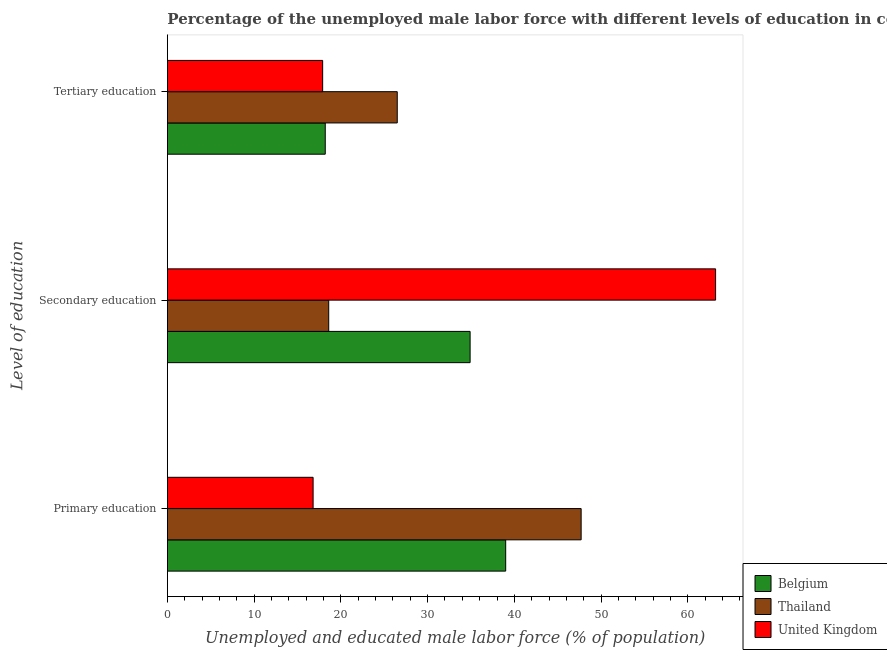Are the number of bars per tick equal to the number of legend labels?
Your response must be concise. Yes. How many bars are there on the 1st tick from the top?
Offer a terse response. 3. How many bars are there on the 1st tick from the bottom?
Provide a succinct answer. 3. What is the label of the 3rd group of bars from the top?
Your answer should be very brief. Primary education. What is the percentage of male labor force who received secondary education in United Kingdom?
Keep it short and to the point. 63.2. Across all countries, what is the maximum percentage of male labor force who received secondary education?
Make the answer very short. 63.2. Across all countries, what is the minimum percentage of male labor force who received primary education?
Provide a succinct answer. 16.8. In which country was the percentage of male labor force who received primary education minimum?
Provide a succinct answer. United Kingdom. What is the total percentage of male labor force who received primary education in the graph?
Your answer should be compact. 103.5. What is the difference between the percentage of male labor force who received tertiary education in Belgium and that in United Kingdom?
Offer a very short reply. 0.3. What is the difference between the percentage of male labor force who received secondary education in Belgium and the percentage of male labor force who received primary education in Thailand?
Your response must be concise. -12.8. What is the average percentage of male labor force who received primary education per country?
Give a very brief answer. 34.5. What is the difference between the percentage of male labor force who received tertiary education and percentage of male labor force who received primary education in Belgium?
Provide a succinct answer. -20.8. What is the ratio of the percentage of male labor force who received primary education in Thailand to that in United Kingdom?
Your answer should be very brief. 2.84. Is the difference between the percentage of male labor force who received secondary education in United Kingdom and Belgium greater than the difference between the percentage of male labor force who received primary education in United Kingdom and Belgium?
Provide a short and direct response. Yes. What is the difference between the highest and the second highest percentage of male labor force who received primary education?
Provide a succinct answer. 8.7. What is the difference between the highest and the lowest percentage of male labor force who received primary education?
Your answer should be compact. 30.9. What does the 2nd bar from the top in Tertiary education represents?
Your response must be concise. Thailand. What does the 1st bar from the bottom in Primary education represents?
Your answer should be very brief. Belgium. Is it the case that in every country, the sum of the percentage of male labor force who received primary education and percentage of male labor force who received secondary education is greater than the percentage of male labor force who received tertiary education?
Ensure brevity in your answer.  Yes. How many bars are there?
Offer a very short reply. 9. How many countries are there in the graph?
Make the answer very short. 3. Are the values on the major ticks of X-axis written in scientific E-notation?
Keep it short and to the point. No. Does the graph contain any zero values?
Keep it short and to the point. No. Where does the legend appear in the graph?
Provide a succinct answer. Bottom right. How many legend labels are there?
Your answer should be very brief. 3. How are the legend labels stacked?
Keep it short and to the point. Vertical. What is the title of the graph?
Keep it short and to the point. Percentage of the unemployed male labor force with different levels of education in countries. Does "Least developed countries" appear as one of the legend labels in the graph?
Your answer should be very brief. No. What is the label or title of the X-axis?
Give a very brief answer. Unemployed and educated male labor force (% of population). What is the label or title of the Y-axis?
Your response must be concise. Level of education. What is the Unemployed and educated male labor force (% of population) in Belgium in Primary education?
Give a very brief answer. 39. What is the Unemployed and educated male labor force (% of population) in Thailand in Primary education?
Give a very brief answer. 47.7. What is the Unemployed and educated male labor force (% of population) of United Kingdom in Primary education?
Give a very brief answer. 16.8. What is the Unemployed and educated male labor force (% of population) of Belgium in Secondary education?
Offer a very short reply. 34.9. What is the Unemployed and educated male labor force (% of population) in Thailand in Secondary education?
Offer a terse response. 18.6. What is the Unemployed and educated male labor force (% of population) of United Kingdom in Secondary education?
Ensure brevity in your answer.  63.2. What is the Unemployed and educated male labor force (% of population) of Belgium in Tertiary education?
Make the answer very short. 18.2. What is the Unemployed and educated male labor force (% of population) in United Kingdom in Tertiary education?
Your response must be concise. 17.9. Across all Level of education, what is the maximum Unemployed and educated male labor force (% of population) of Belgium?
Provide a succinct answer. 39. Across all Level of education, what is the maximum Unemployed and educated male labor force (% of population) in Thailand?
Provide a succinct answer. 47.7. Across all Level of education, what is the maximum Unemployed and educated male labor force (% of population) in United Kingdom?
Provide a short and direct response. 63.2. Across all Level of education, what is the minimum Unemployed and educated male labor force (% of population) of Belgium?
Your answer should be compact. 18.2. Across all Level of education, what is the minimum Unemployed and educated male labor force (% of population) in Thailand?
Your response must be concise. 18.6. Across all Level of education, what is the minimum Unemployed and educated male labor force (% of population) of United Kingdom?
Ensure brevity in your answer.  16.8. What is the total Unemployed and educated male labor force (% of population) in Belgium in the graph?
Give a very brief answer. 92.1. What is the total Unemployed and educated male labor force (% of population) of Thailand in the graph?
Keep it short and to the point. 92.8. What is the total Unemployed and educated male labor force (% of population) in United Kingdom in the graph?
Offer a terse response. 97.9. What is the difference between the Unemployed and educated male labor force (% of population) in Thailand in Primary education and that in Secondary education?
Offer a terse response. 29.1. What is the difference between the Unemployed and educated male labor force (% of population) in United Kingdom in Primary education and that in Secondary education?
Your answer should be compact. -46.4. What is the difference between the Unemployed and educated male labor force (% of population) in Belgium in Primary education and that in Tertiary education?
Provide a short and direct response. 20.8. What is the difference between the Unemployed and educated male labor force (% of population) in Thailand in Primary education and that in Tertiary education?
Provide a succinct answer. 21.2. What is the difference between the Unemployed and educated male labor force (% of population) of United Kingdom in Secondary education and that in Tertiary education?
Your response must be concise. 45.3. What is the difference between the Unemployed and educated male labor force (% of population) of Belgium in Primary education and the Unemployed and educated male labor force (% of population) of Thailand in Secondary education?
Your response must be concise. 20.4. What is the difference between the Unemployed and educated male labor force (% of population) in Belgium in Primary education and the Unemployed and educated male labor force (% of population) in United Kingdom in Secondary education?
Offer a terse response. -24.2. What is the difference between the Unemployed and educated male labor force (% of population) of Thailand in Primary education and the Unemployed and educated male labor force (% of population) of United Kingdom in Secondary education?
Offer a terse response. -15.5. What is the difference between the Unemployed and educated male labor force (% of population) in Belgium in Primary education and the Unemployed and educated male labor force (% of population) in United Kingdom in Tertiary education?
Offer a terse response. 21.1. What is the difference between the Unemployed and educated male labor force (% of population) of Thailand in Primary education and the Unemployed and educated male labor force (% of population) of United Kingdom in Tertiary education?
Keep it short and to the point. 29.8. What is the difference between the Unemployed and educated male labor force (% of population) of Belgium in Secondary education and the Unemployed and educated male labor force (% of population) of Thailand in Tertiary education?
Give a very brief answer. 8.4. What is the difference between the Unemployed and educated male labor force (% of population) of Belgium in Secondary education and the Unemployed and educated male labor force (% of population) of United Kingdom in Tertiary education?
Give a very brief answer. 17. What is the average Unemployed and educated male labor force (% of population) in Belgium per Level of education?
Your response must be concise. 30.7. What is the average Unemployed and educated male labor force (% of population) in Thailand per Level of education?
Your answer should be compact. 30.93. What is the average Unemployed and educated male labor force (% of population) of United Kingdom per Level of education?
Make the answer very short. 32.63. What is the difference between the Unemployed and educated male labor force (% of population) in Thailand and Unemployed and educated male labor force (% of population) in United Kingdom in Primary education?
Provide a short and direct response. 30.9. What is the difference between the Unemployed and educated male labor force (% of population) of Belgium and Unemployed and educated male labor force (% of population) of United Kingdom in Secondary education?
Provide a succinct answer. -28.3. What is the difference between the Unemployed and educated male labor force (% of population) in Thailand and Unemployed and educated male labor force (% of population) in United Kingdom in Secondary education?
Give a very brief answer. -44.6. What is the difference between the Unemployed and educated male labor force (% of population) in Belgium and Unemployed and educated male labor force (% of population) in Thailand in Tertiary education?
Your answer should be very brief. -8.3. What is the difference between the Unemployed and educated male labor force (% of population) of Belgium and Unemployed and educated male labor force (% of population) of United Kingdom in Tertiary education?
Provide a short and direct response. 0.3. What is the difference between the Unemployed and educated male labor force (% of population) in Thailand and Unemployed and educated male labor force (% of population) in United Kingdom in Tertiary education?
Provide a succinct answer. 8.6. What is the ratio of the Unemployed and educated male labor force (% of population) of Belgium in Primary education to that in Secondary education?
Give a very brief answer. 1.12. What is the ratio of the Unemployed and educated male labor force (% of population) of Thailand in Primary education to that in Secondary education?
Give a very brief answer. 2.56. What is the ratio of the Unemployed and educated male labor force (% of population) in United Kingdom in Primary education to that in Secondary education?
Provide a succinct answer. 0.27. What is the ratio of the Unemployed and educated male labor force (% of population) in Belgium in Primary education to that in Tertiary education?
Make the answer very short. 2.14. What is the ratio of the Unemployed and educated male labor force (% of population) of United Kingdom in Primary education to that in Tertiary education?
Provide a short and direct response. 0.94. What is the ratio of the Unemployed and educated male labor force (% of population) of Belgium in Secondary education to that in Tertiary education?
Provide a succinct answer. 1.92. What is the ratio of the Unemployed and educated male labor force (% of population) of Thailand in Secondary education to that in Tertiary education?
Provide a short and direct response. 0.7. What is the ratio of the Unemployed and educated male labor force (% of population) in United Kingdom in Secondary education to that in Tertiary education?
Make the answer very short. 3.53. What is the difference between the highest and the second highest Unemployed and educated male labor force (% of population) of Thailand?
Provide a short and direct response. 21.2. What is the difference between the highest and the second highest Unemployed and educated male labor force (% of population) of United Kingdom?
Provide a short and direct response. 45.3. What is the difference between the highest and the lowest Unemployed and educated male labor force (% of population) of Belgium?
Offer a terse response. 20.8. What is the difference between the highest and the lowest Unemployed and educated male labor force (% of population) of Thailand?
Provide a succinct answer. 29.1. What is the difference between the highest and the lowest Unemployed and educated male labor force (% of population) in United Kingdom?
Provide a succinct answer. 46.4. 